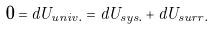Convert formula to latex. <formula><loc_0><loc_0><loc_500><loc_500>0 = d U _ { u n i v . } = d U _ { s y s . } + d U _ { s u r r . }</formula> 